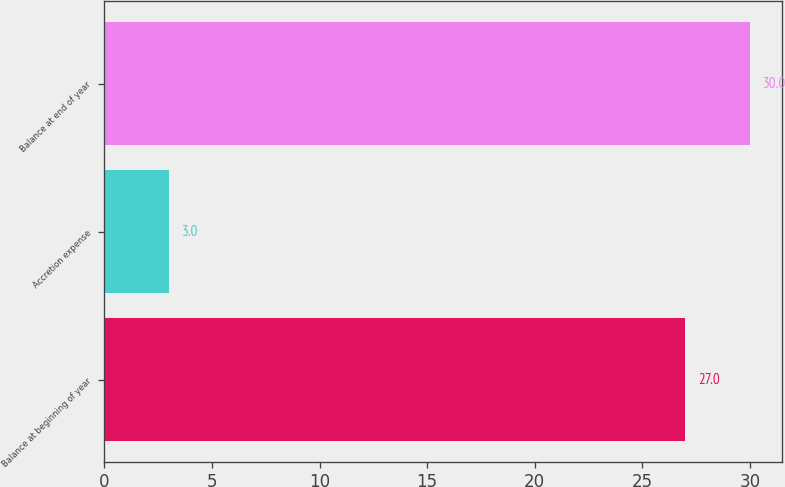<chart> <loc_0><loc_0><loc_500><loc_500><bar_chart><fcel>Balance at beginning of year<fcel>Accretion expense<fcel>Balance at end of year<nl><fcel>27<fcel>3<fcel>30<nl></chart> 